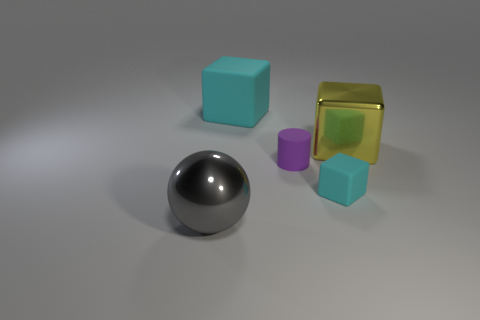Add 4 cylinders. How many objects exist? 9 Subtract all balls. How many objects are left? 4 Add 4 gray things. How many gray things are left? 5 Add 4 tiny brown cubes. How many tiny brown cubes exist? 4 Subtract 1 gray spheres. How many objects are left? 4 Subtract all gray metal objects. Subtract all small purple matte objects. How many objects are left? 3 